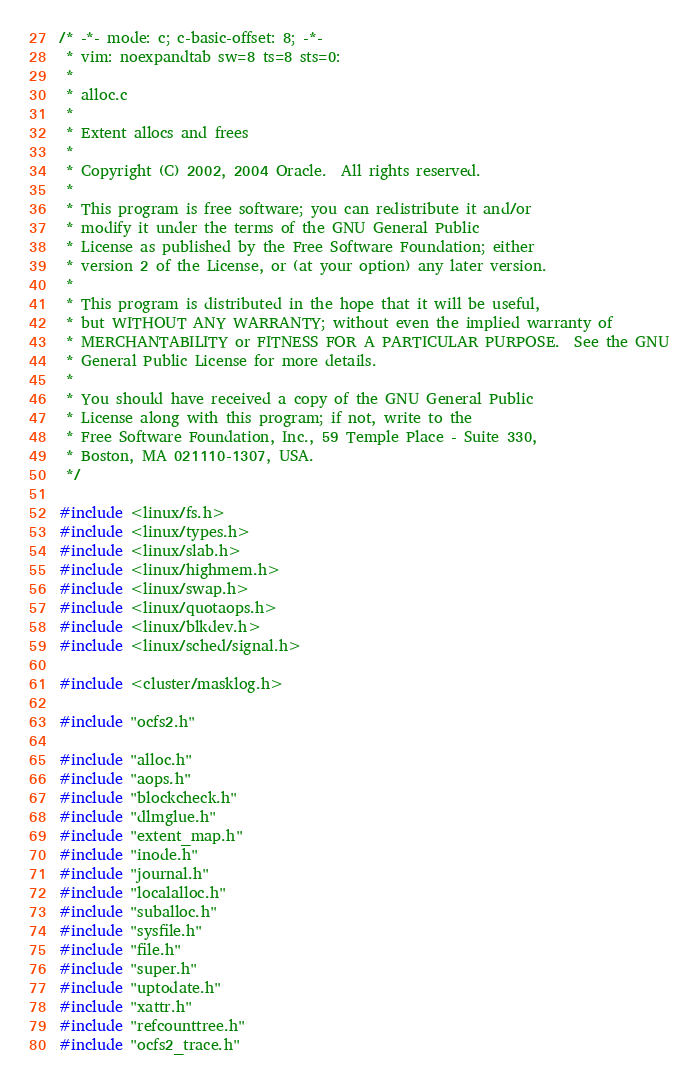<code> <loc_0><loc_0><loc_500><loc_500><_C_>/* -*- mode: c; c-basic-offset: 8; -*-
 * vim: noexpandtab sw=8 ts=8 sts=0:
 *
 * alloc.c
 *
 * Extent allocs and frees
 *
 * Copyright (C) 2002, 2004 Oracle.  All rights reserved.
 *
 * This program is free software; you can redistribute it and/or
 * modify it under the terms of the GNU General Public
 * License as published by the Free Software Foundation; either
 * version 2 of the License, or (at your option) any later version.
 *
 * This program is distributed in the hope that it will be useful,
 * but WITHOUT ANY WARRANTY; without even the implied warranty of
 * MERCHANTABILITY or FITNESS FOR A PARTICULAR PURPOSE.  See the GNU
 * General Public License for more details.
 *
 * You should have received a copy of the GNU General Public
 * License along with this program; if not, write to the
 * Free Software Foundation, Inc., 59 Temple Place - Suite 330,
 * Boston, MA 021110-1307, USA.
 */

#include <linux/fs.h>
#include <linux/types.h>
#include <linux/slab.h>
#include <linux/highmem.h>
#include <linux/swap.h>
#include <linux/quotaops.h>
#include <linux/blkdev.h>
#include <linux/sched/signal.h>

#include <cluster/masklog.h>

#include "ocfs2.h"

#include "alloc.h"
#include "aops.h"
#include "blockcheck.h"
#include "dlmglue.h"
#include "extent_map.h"
#include "inode.h"
#include "journal.h"
#include "localalloc.h"
#include "suballoc.h"
#include "sysfile.h"
#include "file.h"
#include "super.h"
#include "uptodate.h"
#include "xattr.h"
#include "refcounttree.h"
#include "ocfs2_trace.h"
</code> 